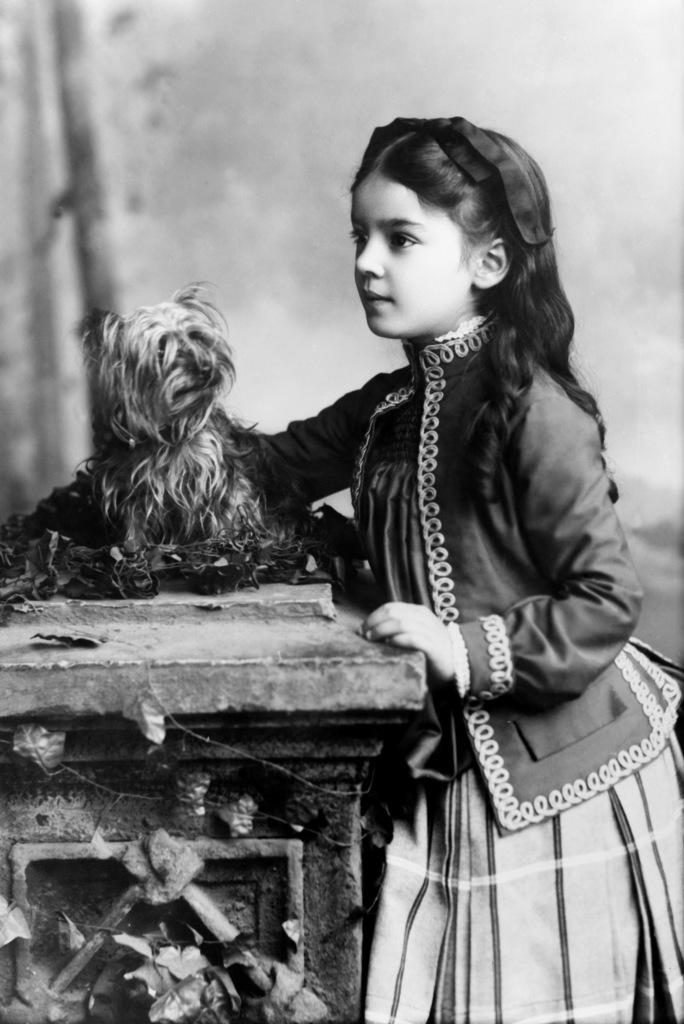Who is the main subject in the image? There is a girl in the image. What is the girl doing in the image? The girl is standing. What other object can be seen on a table in the image? There is a dog on a table in the image. What color scheme is used in the image? The image is in black and white color. What type of destruction is the girl causing in the image? There is no destruction present in the image; the girl is simply standing. How many cattle can be seen in the image? There are no cattle present in the image. 